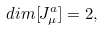Convert formula to latex. <formula><loc_0><loc_0><loc_500><loc_500>d i m [ J _ { \mu } ^ { a } ] = 2 ,</formula> 